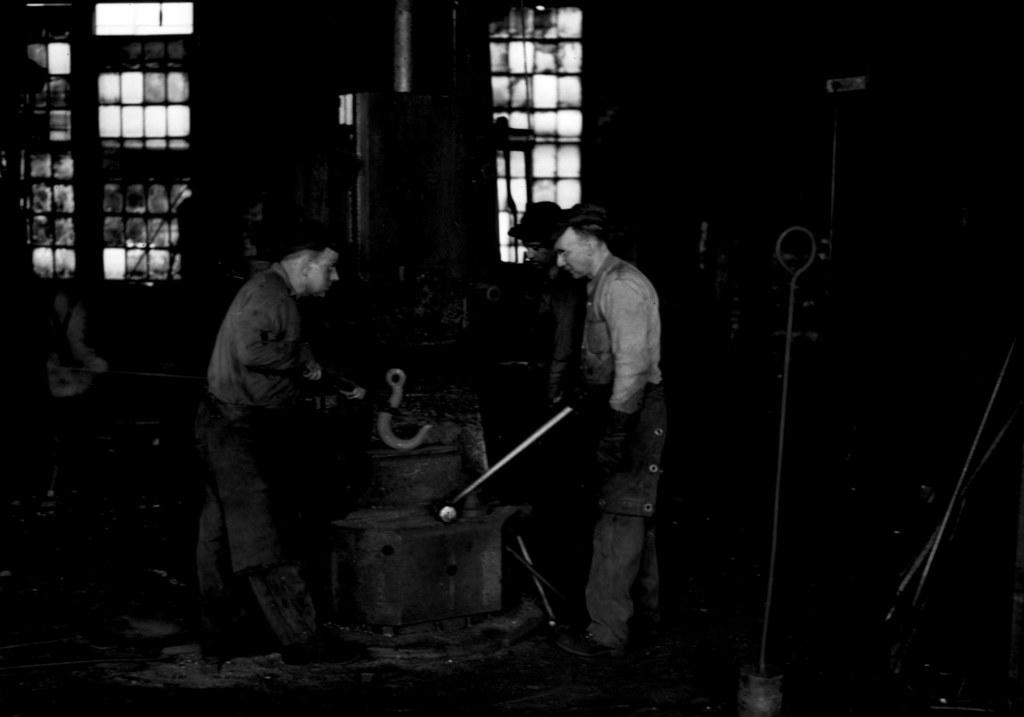What is the main subject of the image? The main subject of the image is a group of people. people. Can you describe the man in the middle of the image? The man in the middle of the image is holding a hammer. What can be seen in the background of the image? There are windows visible in the background of the image. What language is the man speaking to the visitor in the image? There is no visitor present in the image, and the man is not speaking to anyone. 